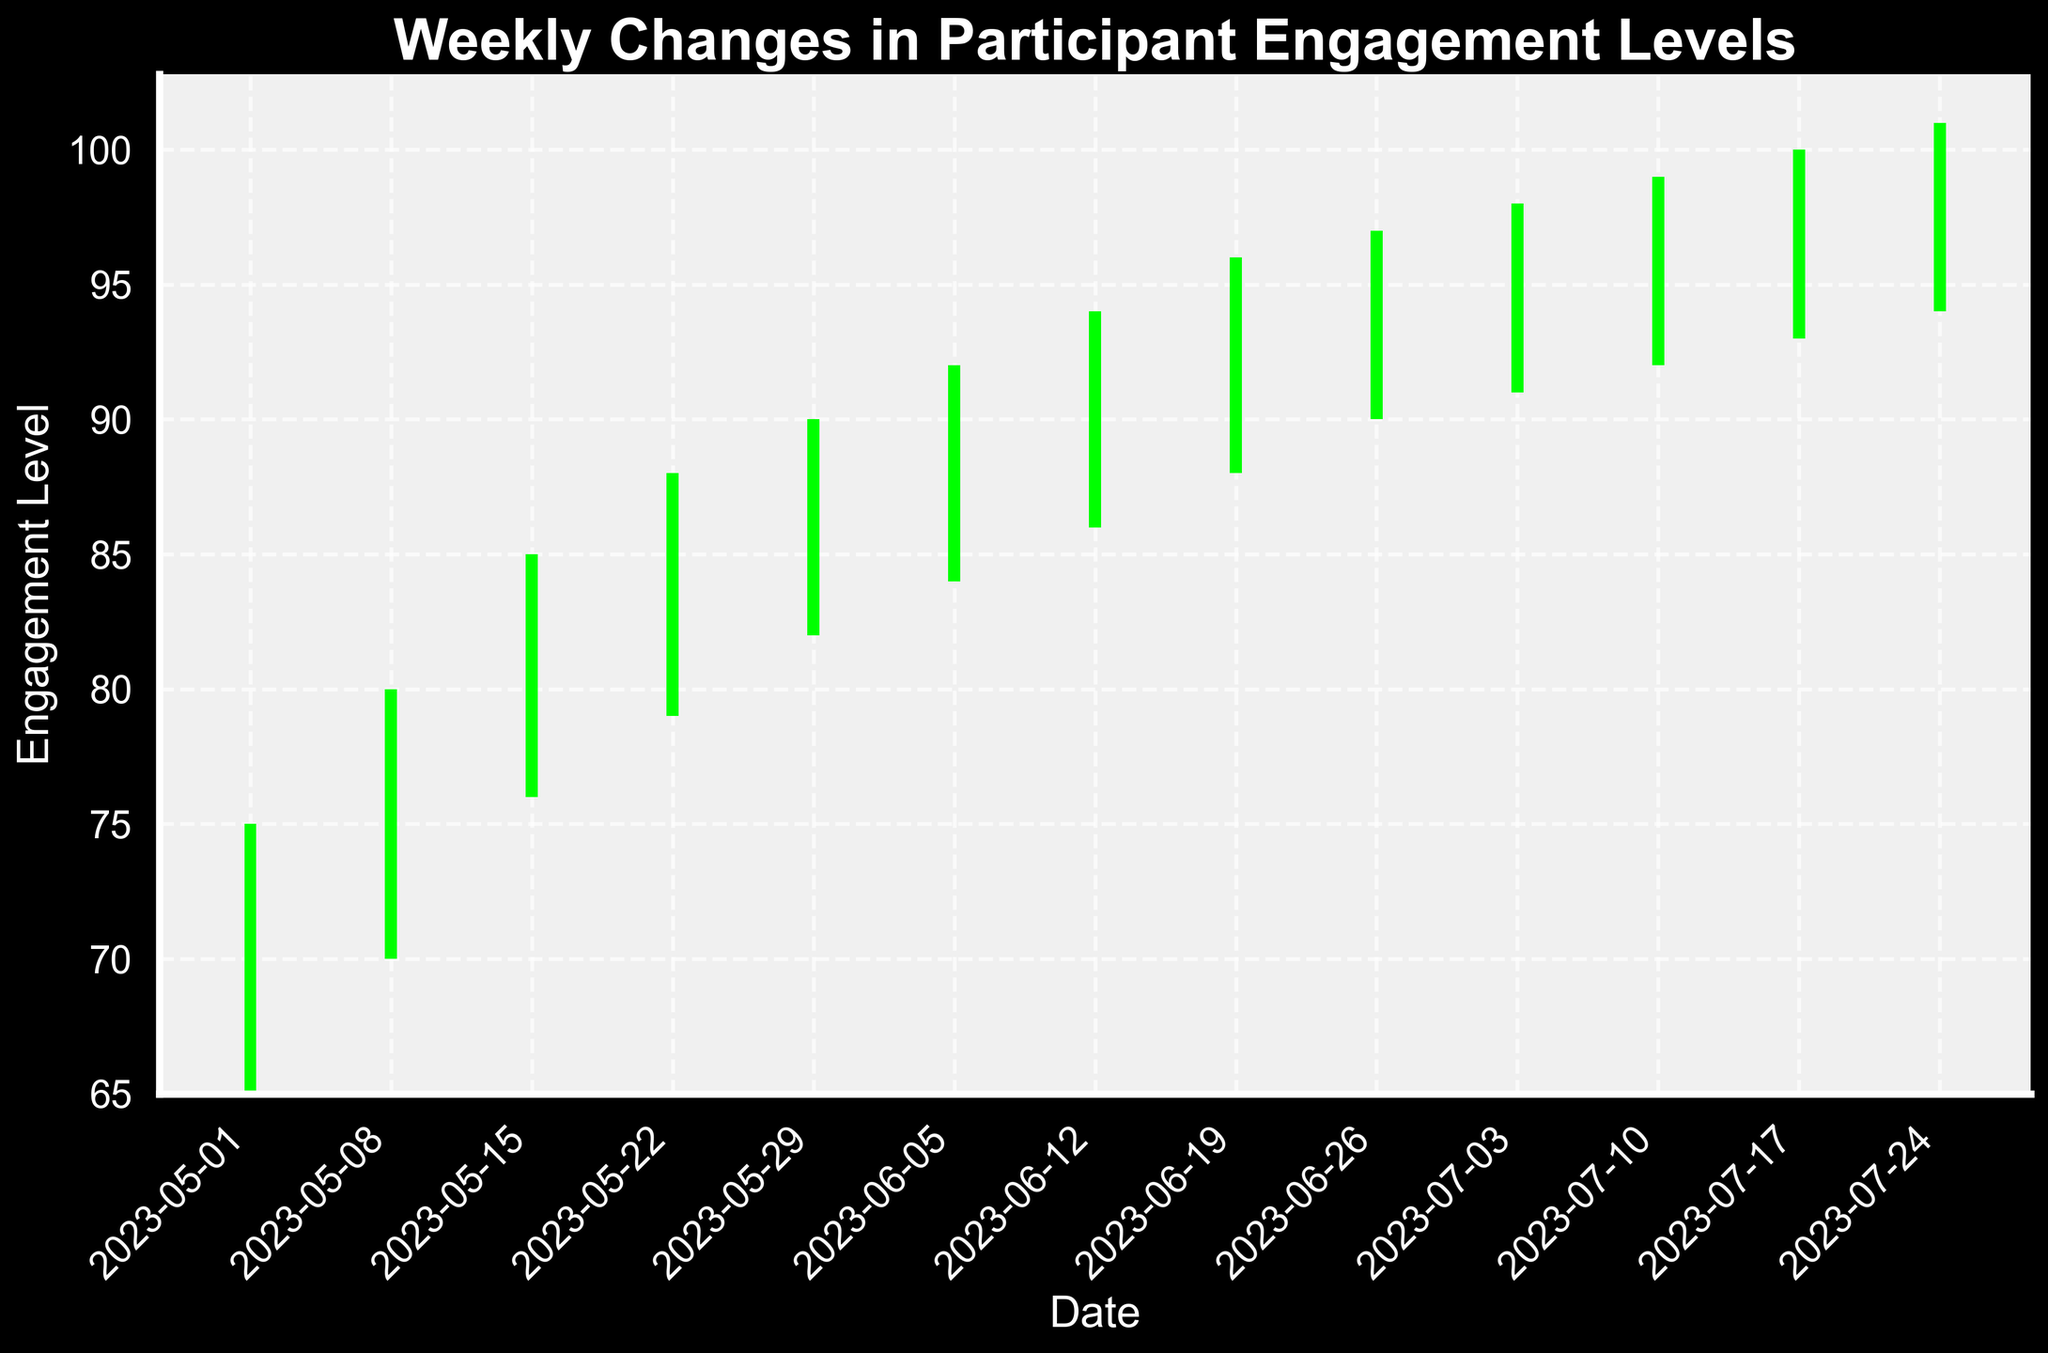What is the title of the figure? The title of the figure is displayed at the top of the chart in bold text.
Answer: Weekly Changes in Participant Engagement Levels What is the color used for weeks where participant engagement levels closed higher than they opened? In the figure, bars indicating weeks where engagement levels closed higher than they opened are colored green.
Answer: Green What is the date range covered by this figure? The date range can be determined from the x-axis ticks, which show dates from early May to late July.
Answer: 2023-05-01 to 2023-07-24 On which date did the participant engagement level reach its highest high? By looking at the highest points in the 'High' bars, we can see that the highest value is 101, which occurred on 2023-07-24.
Answer: 2023-07-24 What was the participant engagement level on 2023-05-01? The engagement levels for any date can be seen by referring to the y-axis corresponding to 'Open', 'High', 'Low', and 'Close' values for that date. On 2023-05-01, the levels were: Open=68, High=75, Low=65, Close=72
Answer: Open=68, High=75, Low=65, Close=72 How many weeks showed a drop in engagement from open to close? Each red bar indicates a week where engagement levels fell from open to close. Counting the red bars gives us the total.
Answer: 0 weeks On which date did the engagement levels have the largest range from low to high? The largest range can be found by calculating the difference between high and low for each date and finding the maximum. The largest range is 12 on 2023-05-08 (High=80, Low=70).
Answer: 2023-05-08 Which date showed the smallest difference between the opening and closing engagement levels? The difference between 'Open' and 'Close' for each date is calculated, and the smallest difference is 1. That occurs on 2023-07-24 (Open=97, Close=98).
Answer: 2023-07-24 How many weeks have engagement levels increased compared to the previous week’s close? To determine this, compare the 'Close' values of each week to the previous week's close value and count the number of times the current week's 'Close' is greater than the previous week's 'Close'.
Answer: 12 weeks 